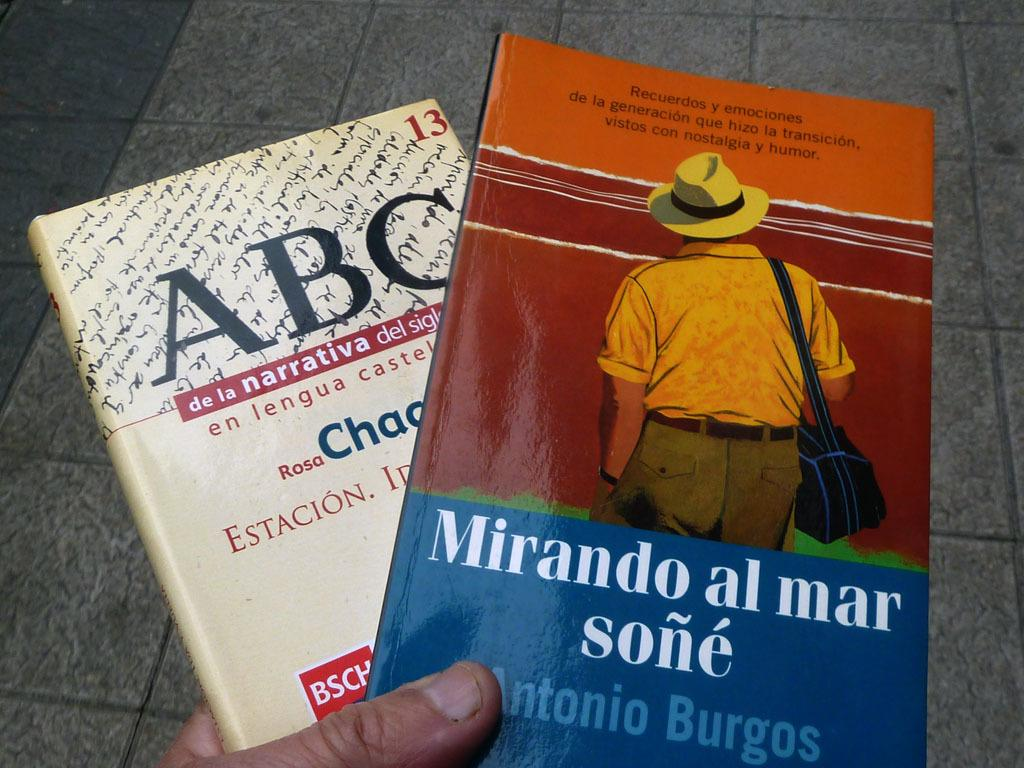<image>
Provide a brief description of the given image. A person holding two books with one titled Mirando al mar sone. 